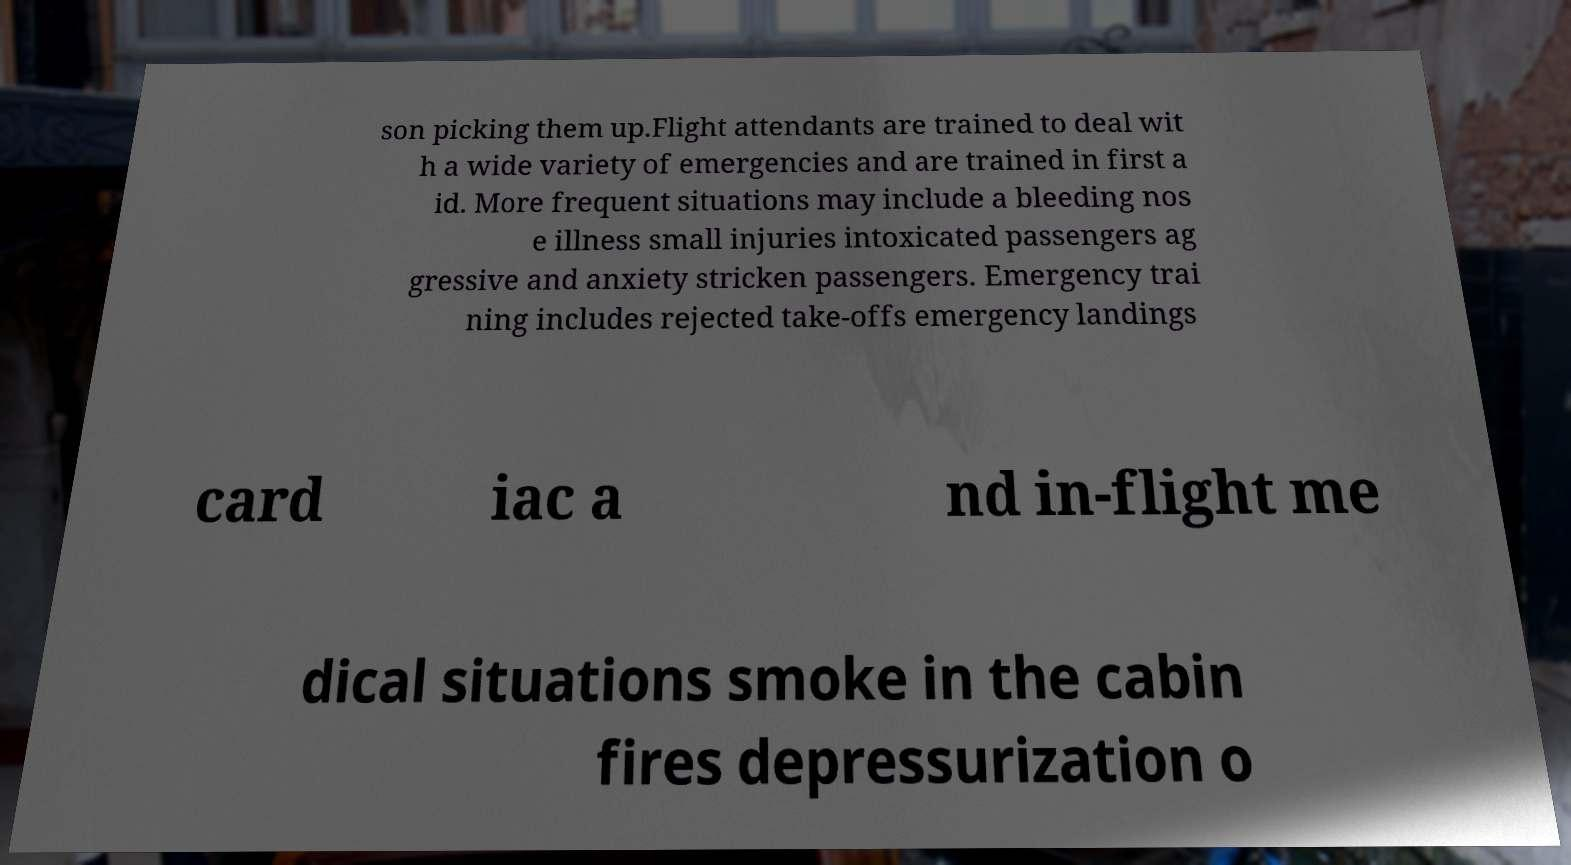Can you read and provide the text displayed in the image?This photo seems to have some interesting text. Can you extract and type it out for me? son picking them up.Flight attendants are trained to deal wit h a wide variety of emergencies and are trained in first a id. More frequent situations may include a bleeding nos e illness small injuries intoxicated passengers ag gressive and anxiety stricken passengers. Emergency trai ning includes rejected take-offs emergency landings card iac a nd in-flight me dical situations smoke in the cabin fires depressurization o 